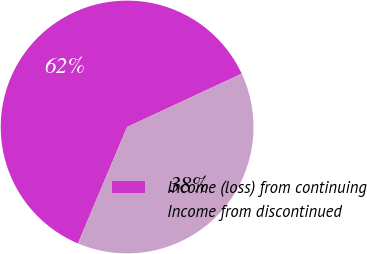Convert chart to OTSL. <chart><loc_0><loc_0><loc_500><loc_500><pie_chart><fcel>Income (loss) from continuing<fcel>Income from discontinued<nl><fcel>61.71%<fcel>38.29%<nl></chart> 